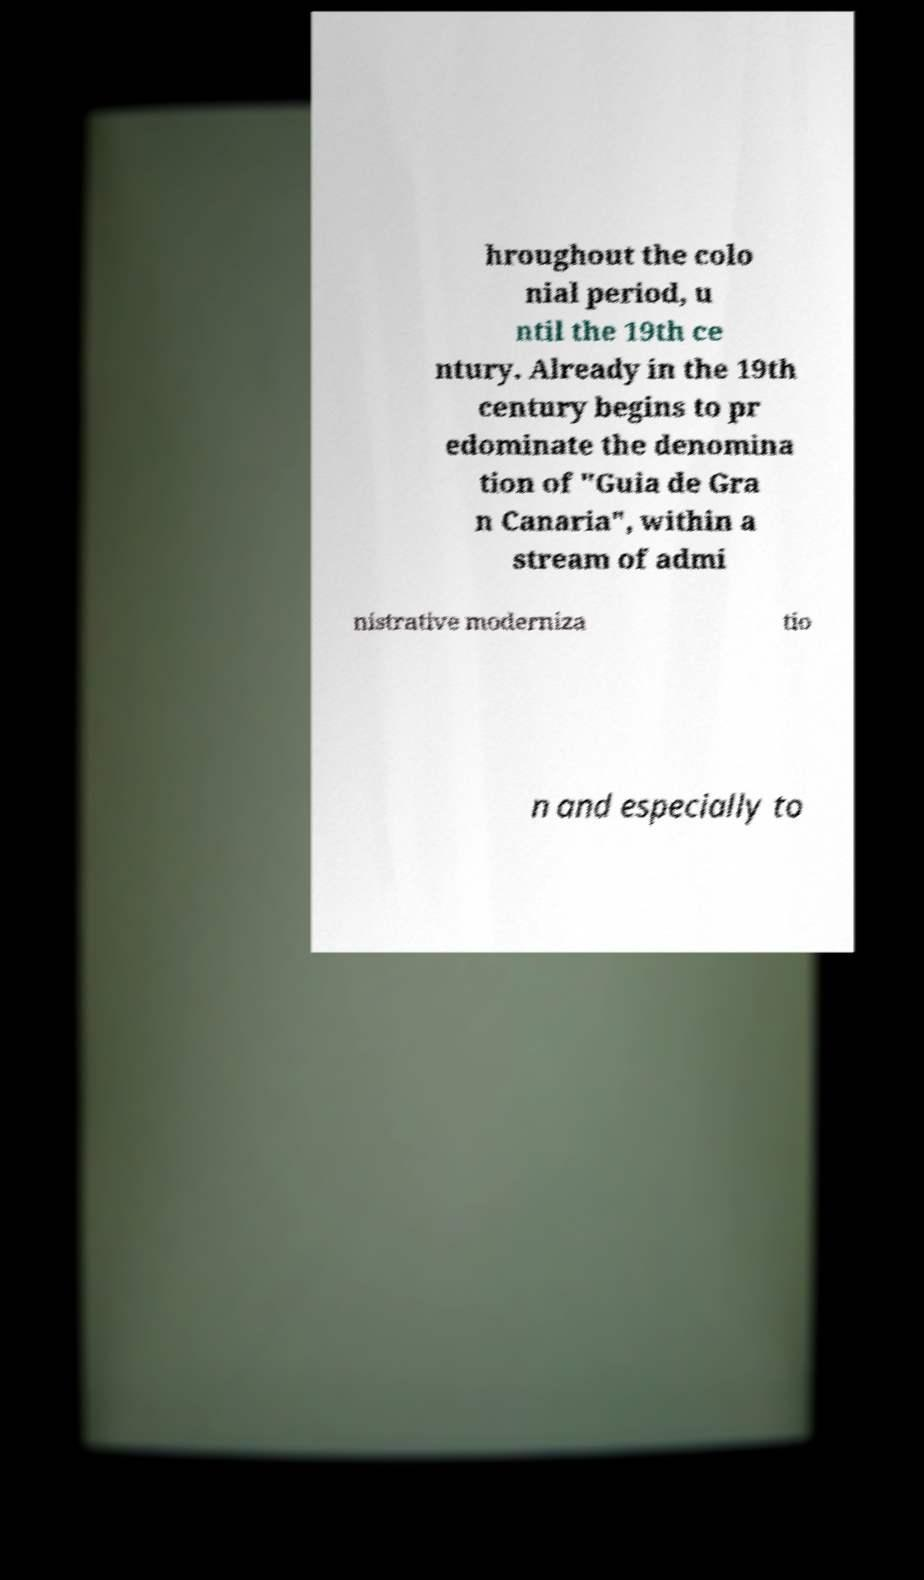For documentation purposes, I need the text within this image transcribed. Could you provide that? hroughout the colo nial period, u ntil the 19th ce ntury. Already in the 19th century begins to pr edominate the denomina tion of "Guia de Gra n Canaria", within a stream of admi nistrative moderniza tio n and especially to 